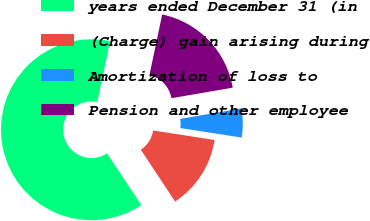Convert chart. <chart><loc_0><loc_0><loc_500><loc_500><pie_chart><fcel>years ended December 31 (in<fcel>(Charge) gain arising during<fcel>Amortization of loss to<fcel>Pension and other employee<nl><fcel>62.6%<fcel>13.25%<fcel>5.16%<fcel>18.99%<nl></chart> 